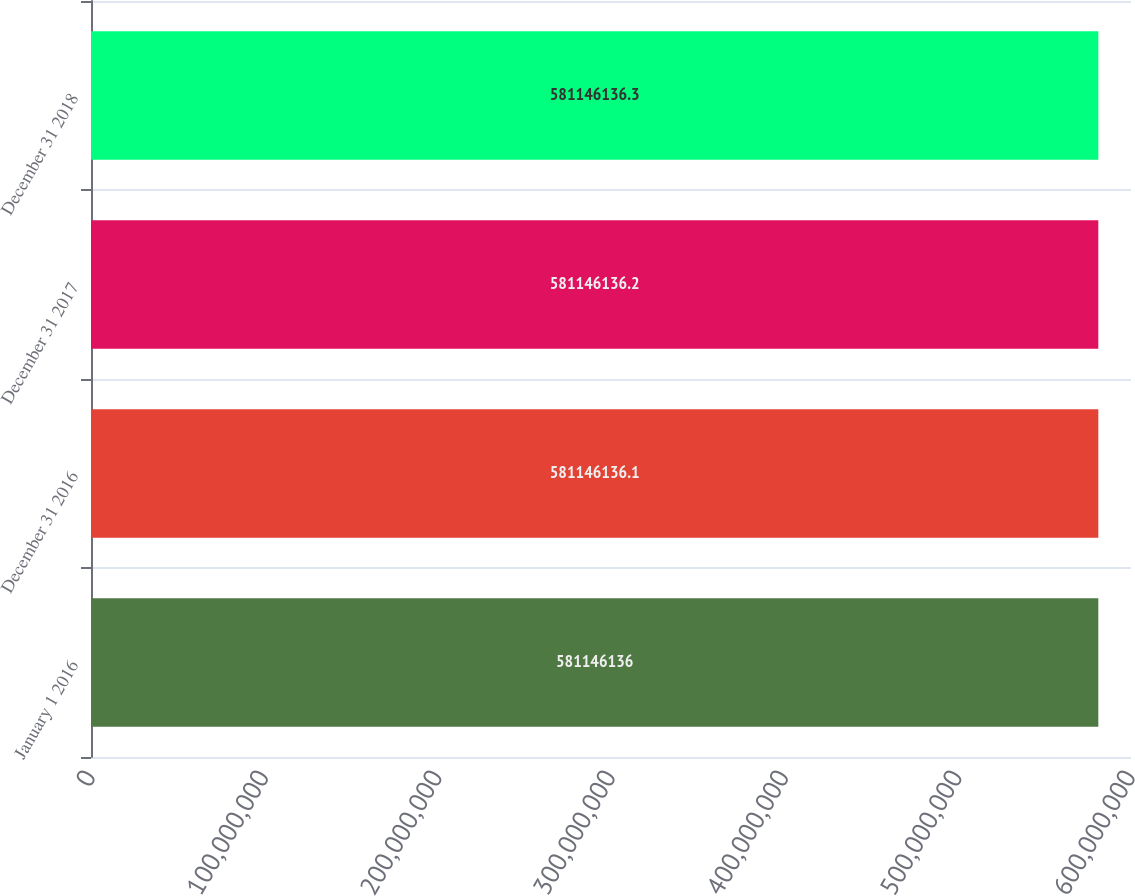<chart> <loc_0><loc_0><loc_500><loc_500><bar_chart><fcel>January 1 2016<fcel>December 31 2016<fcel>December 31 2017<fcel>December 31 2018<nl><fcel>5.81146e+08<fcel>5.81146e+08<fcel>5.81146e+08<fcel>5.81146e+08<nl></chart> 